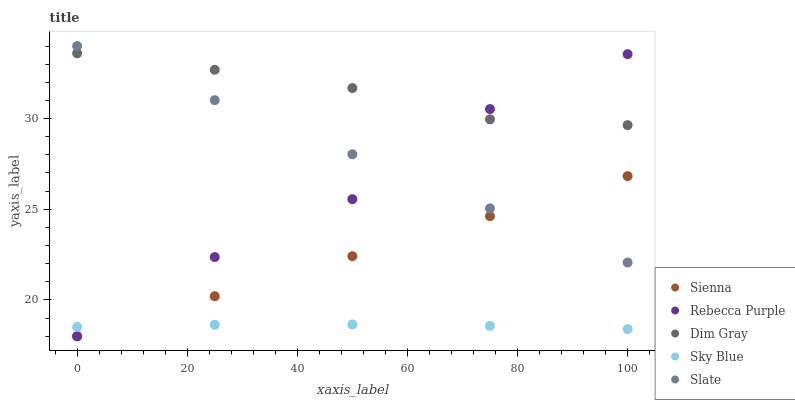Does Sky Blue have the minimum area under the curve?
Answer yes or no. Yes. Does Dim Gray have the maximum area under the curve?
Answer yes or no. Yes. Does Slate have the minimum area under the curve?
Answer yes or no. No. Does Slate have the maximum area under the curve?
Answer yes or no. No. Is Slate the smoothest?
Answer yes or no. Yes. Is Rebecca Purple the roughest?
Answer yes or no. Yes. Is Sky Blue the smoothest?
Answer yes or no. No. Is Sky Blue the roughest?
Answer yes or no. No. Does Sienna have the lowest value?
Answer yes or no. Yes. Does Sky Blue have the lowest value?
Answer yes or no. No. Does Slate have the highest value?
Answer yes or no. Yes. Does Sky Blue have the highest value?
Answer yes or no. No. Is Sienna less than Dim Gray?
Answer yes or no. Yes. Is Dim Gray greater than Sky Blue?
Answer yes or no. Yes. Does Sky Blue intersect Rebecca Purple?
Answer yes or no. Yes. Is Sky Blue less than Rebecca Purple?
Answer yes or no. No. Is Sky Blue greater than Rebecca Purple?
Answer yes or no. No. Does Sienna intersect Dim Gray?
Answer yes or no. No. 